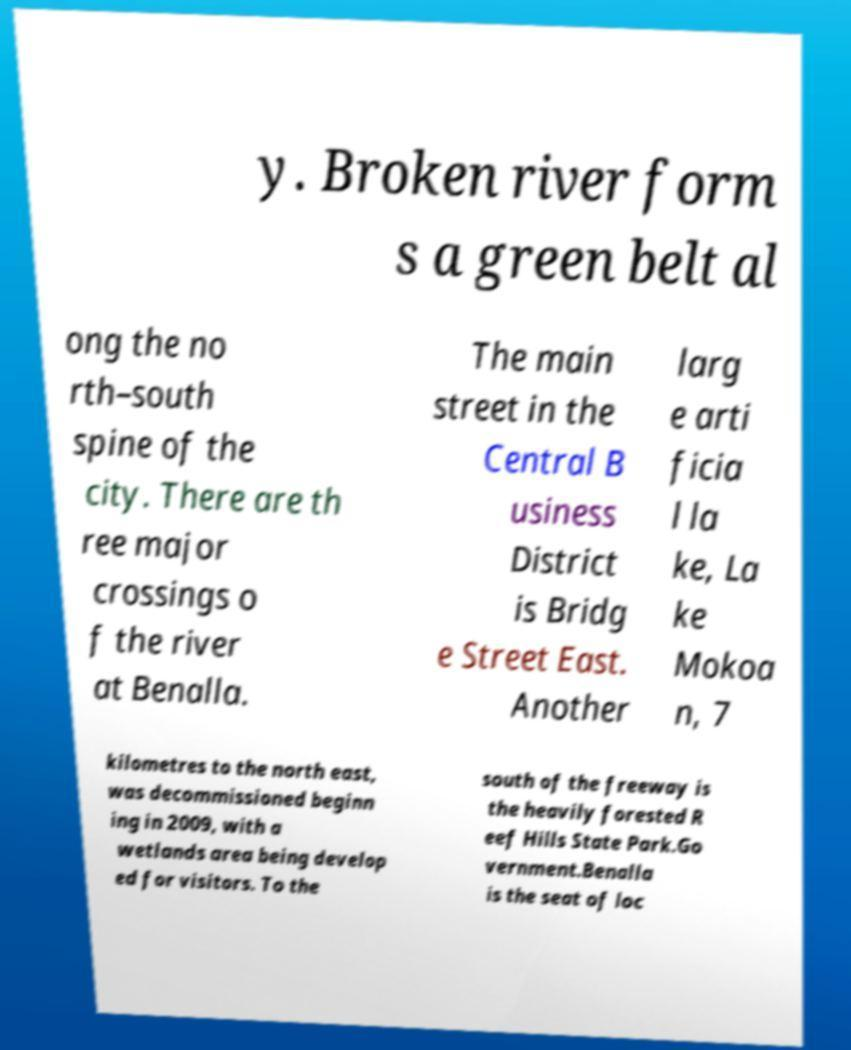Could you assist in decoding the text presented in this image and type it out clearly? y. Broken river form s a green belt al ong the no rth–south spine of the city. There are th ree major crossings o f the river at Benalla. The main street in the Central B usiness District is Bridg e Street East. Another larg e arti ficia l la ke, La ke Mokoa n, 7 kilometres to the north east, was decommissioned beginn ing in 2009, with a wetlands area being develop ed for visitors. To the south of the freeway is the heavily forested R eef Hills State Park.Go vernment.Benalla is the seat of loc 